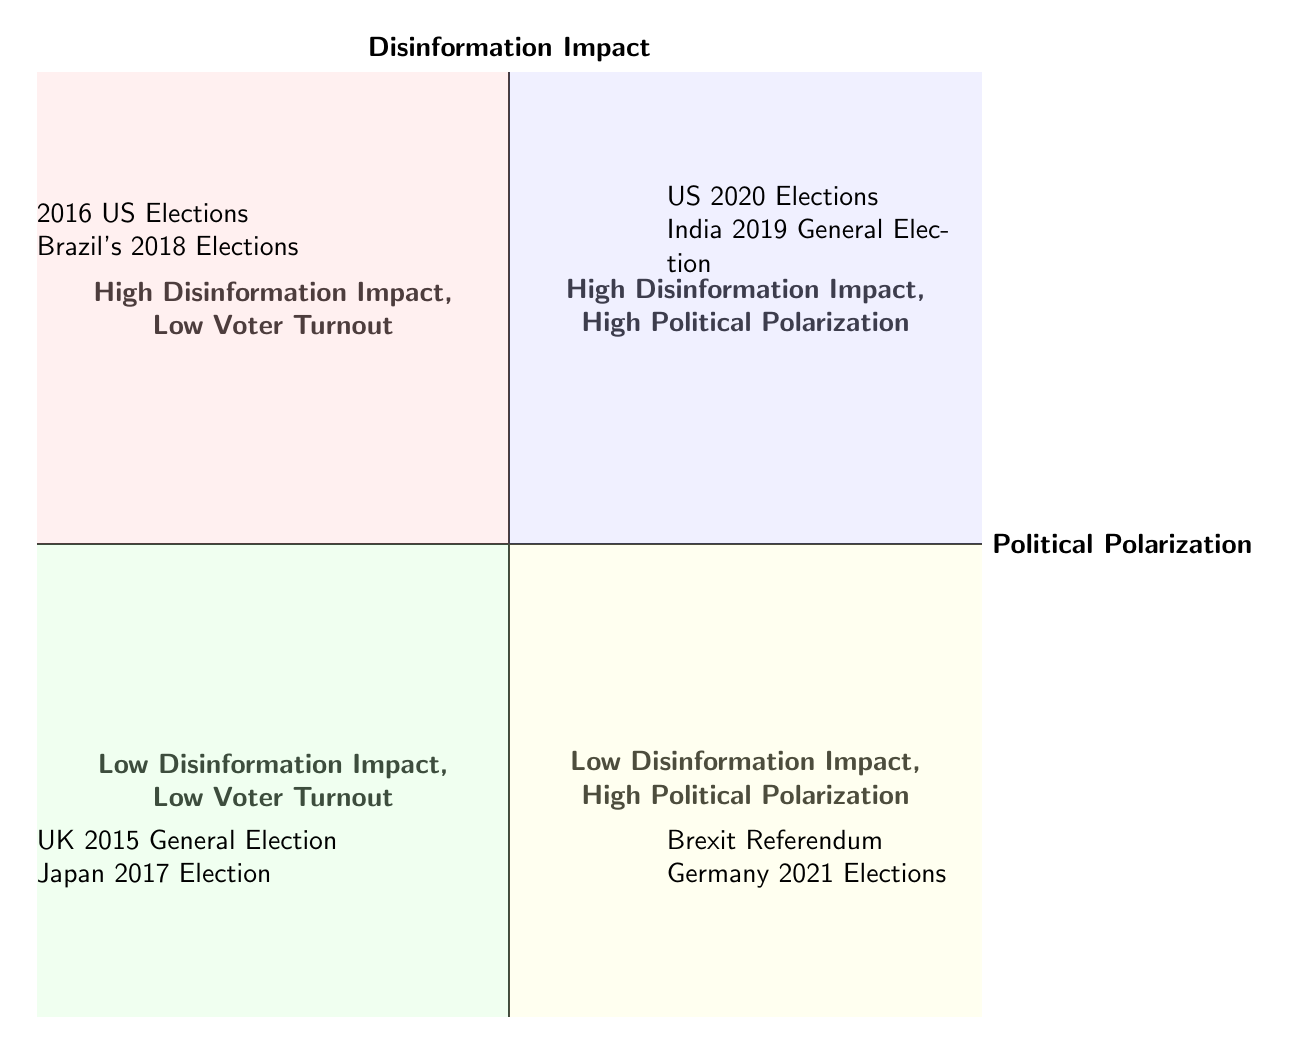What entities are in the "High Disinformation Impact, Low Voter Turnout" quadrant? The entities listed in this quadrant are the 2016 US Elections and Brazil's 2018 Elections.
Answer: 2016 US Elections, Brazil's 2018 Elections How many quadrants are shown in the diagram? The diagram contains four quadrants, each representing different combinations of disinformation impact and political polarization.
Answer: Four What is the main theme of the "Low Disinformation Impact, High Political Polarization" quadrant? This quadrant illustrates cases where political polarization is high despite low levels of disinformation impact, emphasizing other influencing factors.
Answer: Mainstream Misleading Information Which election is associated with deepfake videos? The US 2020 Elections are associated with deepfake videos, impacting political polarization significantly.
Answer: US 2020 Elections How does the presence of disinformation impact voter turnout in the "High Disinformation Impact, High Political Polarization" quadrant? In this quadrant, high disinformation impact correlates with high political polarization but voter turnout is not specifically indicated, suggesting that other factors may also influence turnout.
Answer: Correlates with high polarization What factors are responsible for the polarization in the "Low Disinformation Impact, High Political Polarization" quadrant? The polarization in this quadrant mainly stems from selective news reporting and mainstream information misinterpretation, rather than digital disinformation.
Answer: Selective Reporting by Media 